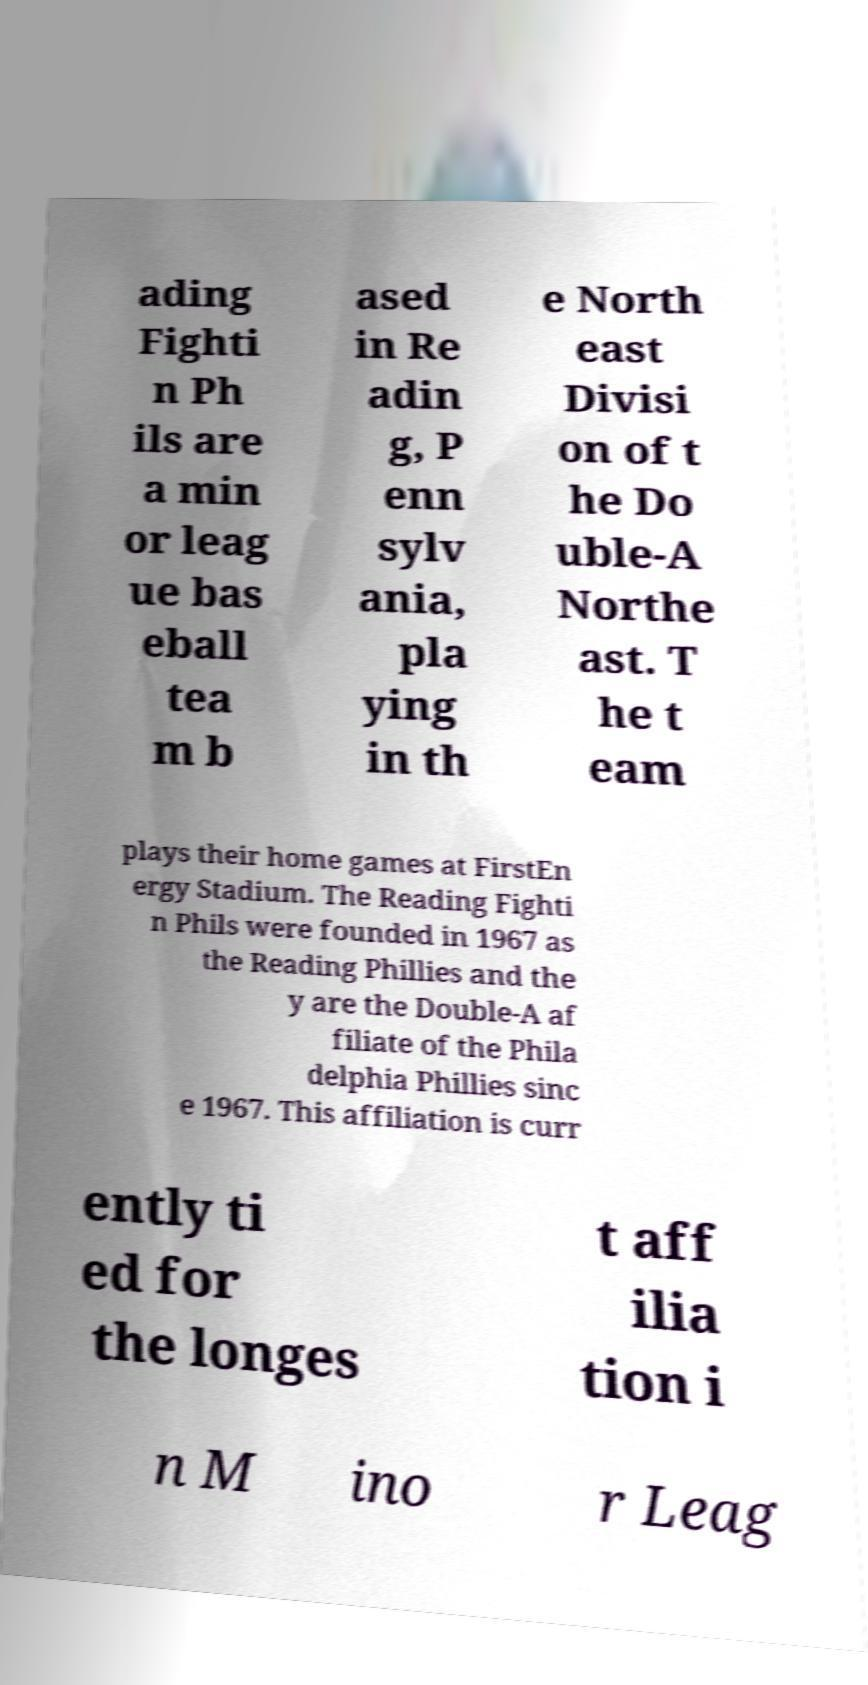Could you extract and type out the text from this image? ading Fighti n Ph ils are a min or leag ue bas eball tea m b ased in Re adin g, P enn sylv ania, pla ying in th e North east Divisi on of t he Do uble-A Northe ast. T he t eam plays their home games at FirstEn ergy Stadium. The Reading Fighti n Phils were founded in 1967 as the Reading Phillies and the y are the Double-A af filiate of the Phila delphia Phillies sinc e 1967. This affiliation is curr ently ti ed for the longes t aff ilia tion i n M ino r Leag 